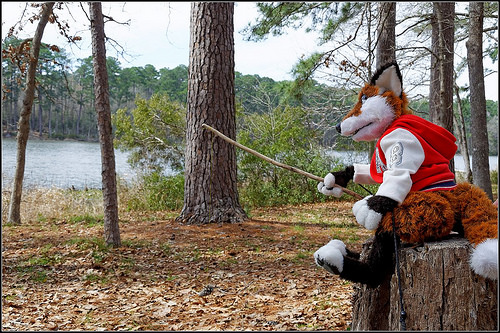<image>
Is there a costume in the woods? No. The costume is not contained within the woods. These objects have a different spatial relationship. 